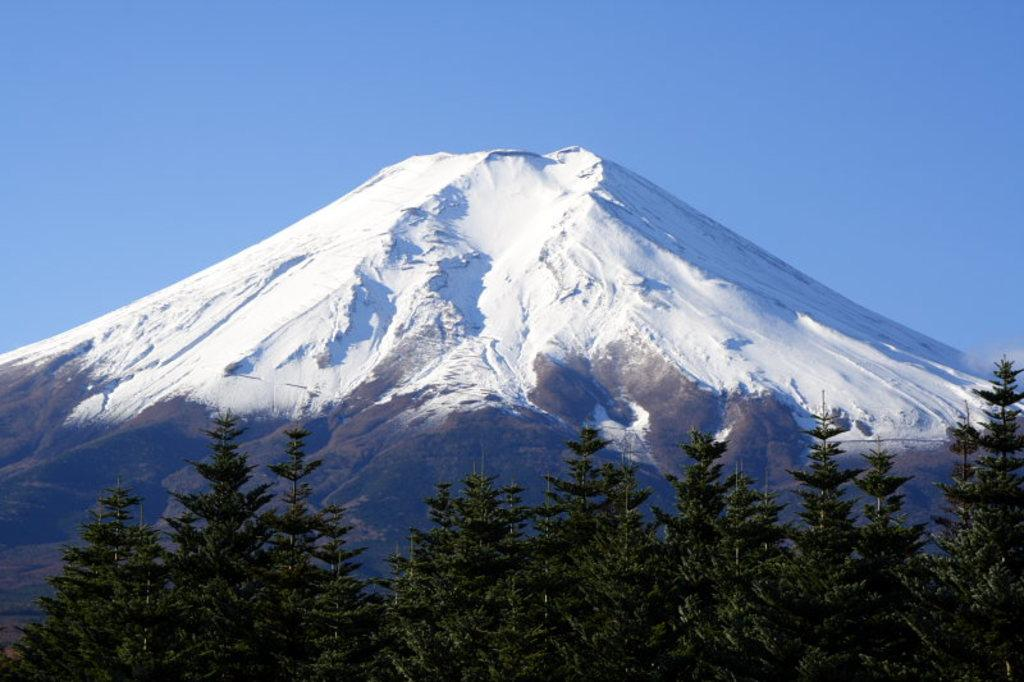What type of vegetation can be seen in the image? There are trees in the image. What geographical feature is present in the image? There is a snowy hill in the image. What is visible in the background of the image? The sky is visible in the image. How many icicles are hanging from the trees in the image? There are no icicles present in the image; it only features trees and a snowy hill. What type of pin can be seen on the snowy hill in the image? There is no pin present in the image; it only features trees, a snowy hill, and the sky. 